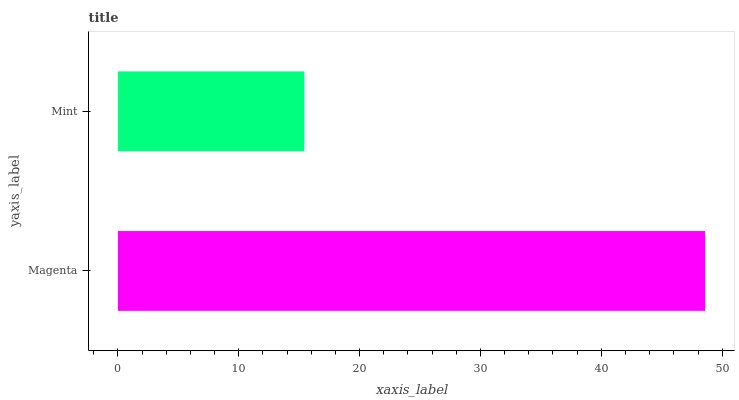Is Mint the minimum?
Answer yes or no. Yes. Is Magenta the maximum?
Answer yes or no. Yes. Is Mint the maximum?
Answer yes or no. No. Is Magenta greater than Mint?
Answer yes or no. Yes. Is Mint less than Magenta?
Answer yes or no. Yes. Is Mint greater than Magenta?
Answer yes or no. No. Is Magenta less than Mint?
Answer yes or no. No. Is Magenta the high median?
Answer yes or no. Yes. Is Mint the low median?
Answer yes or no. Yes. Is Mint the high median?
Answer yes or no. No. Is Magenta the low median?
Answer yes or no. No. 